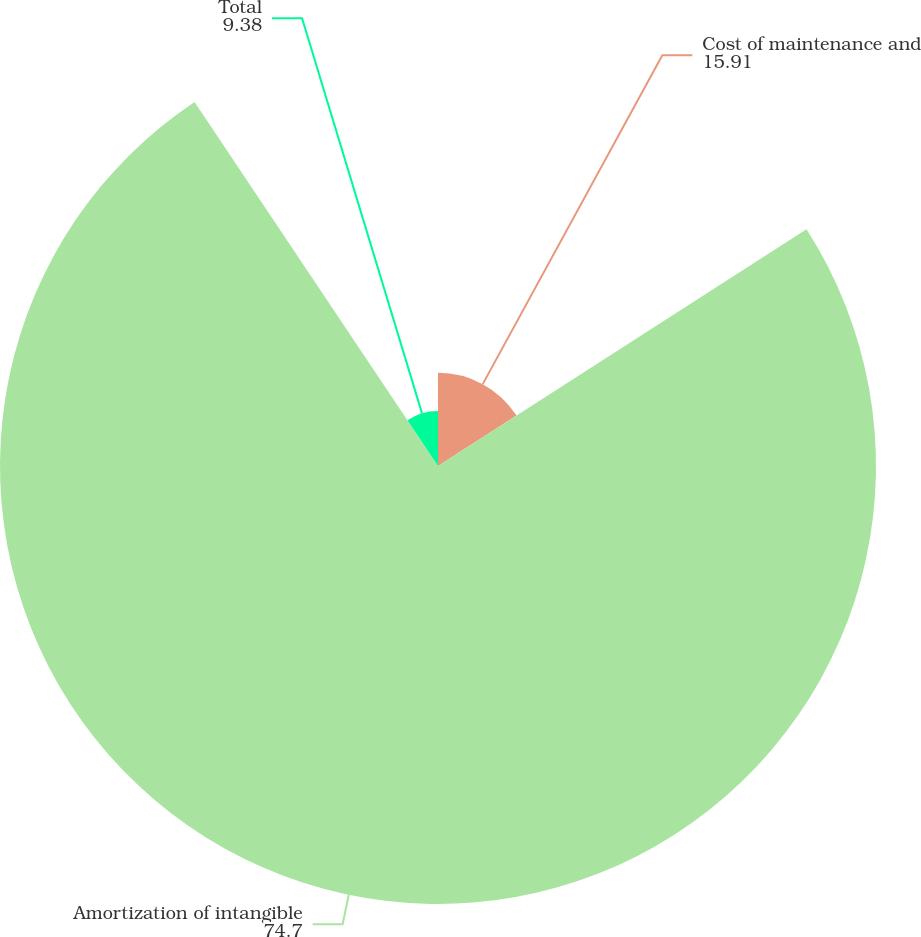Convert chart to OTSL. <chart><loc_0><loc_0><loc_500><loc_500><pie_chart><fcel>Cost of maintenance and<fcel>Amortization of intangible<fcel>Total<nl><fcel>15.91%<fcel>74.7%<fcel>9.38%<nl></chart> 